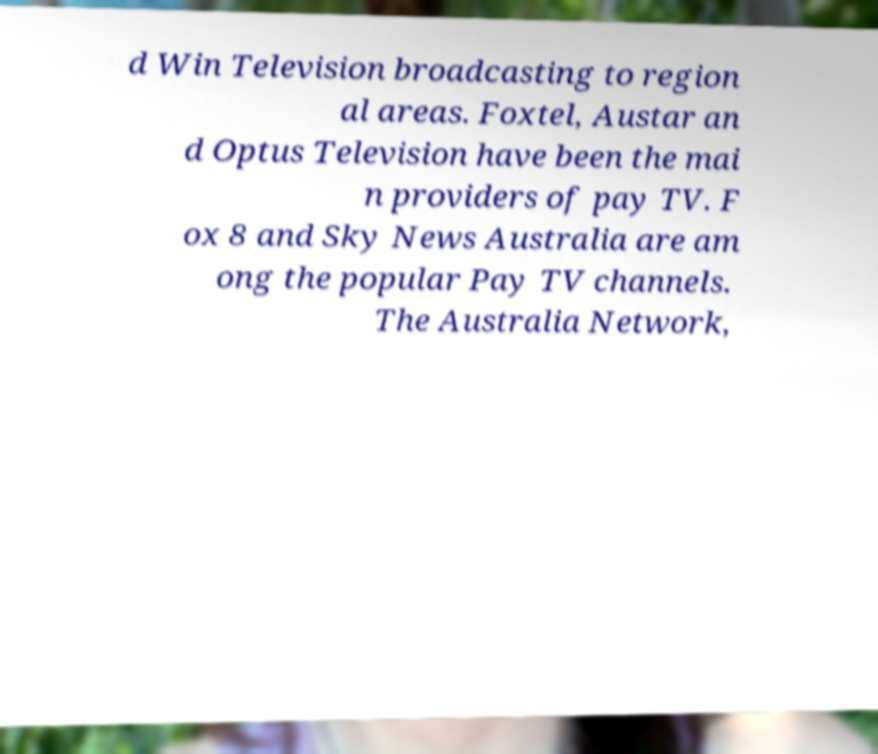Can you accurately transcribe the text from the provided image for me? d Win Television broadcasting to region al areas. Foxtel, Austar an d Optus Television have been the mai n providers of pay TV. F ox 8 and Sky News Australia are am ong the popular Pay TV channels. The Australia Network, 